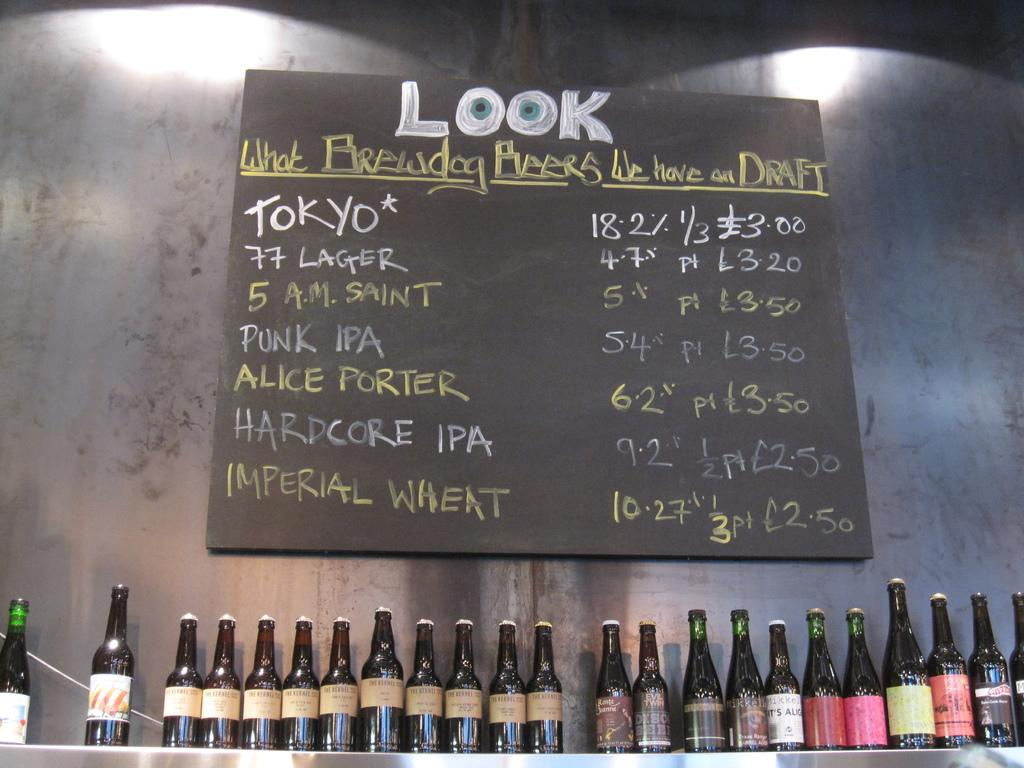<image>
Give a short and clear explanation of the subsequent image. A menu headed with the word LOOK is written in chalk above a row of bottles. 